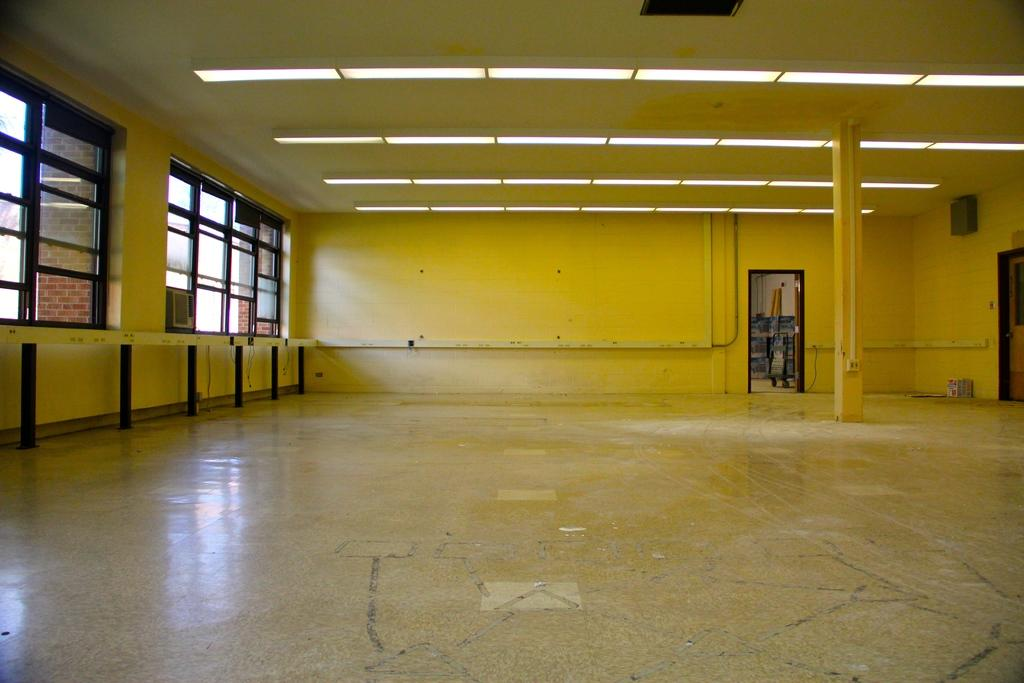What type of setting is shown in the image? The image depicts an inside view of a room. What can be seen in the room that provides illumination? There are lights visible in the room. What object is attached to the wall in the room? There is a box on the wall in the room. What type of vessel is floating in the room in the image? There is no vessel present in the room in the image. How many houses are visible in the image? The image only shows an inside view of a room, so no houses are visible. 